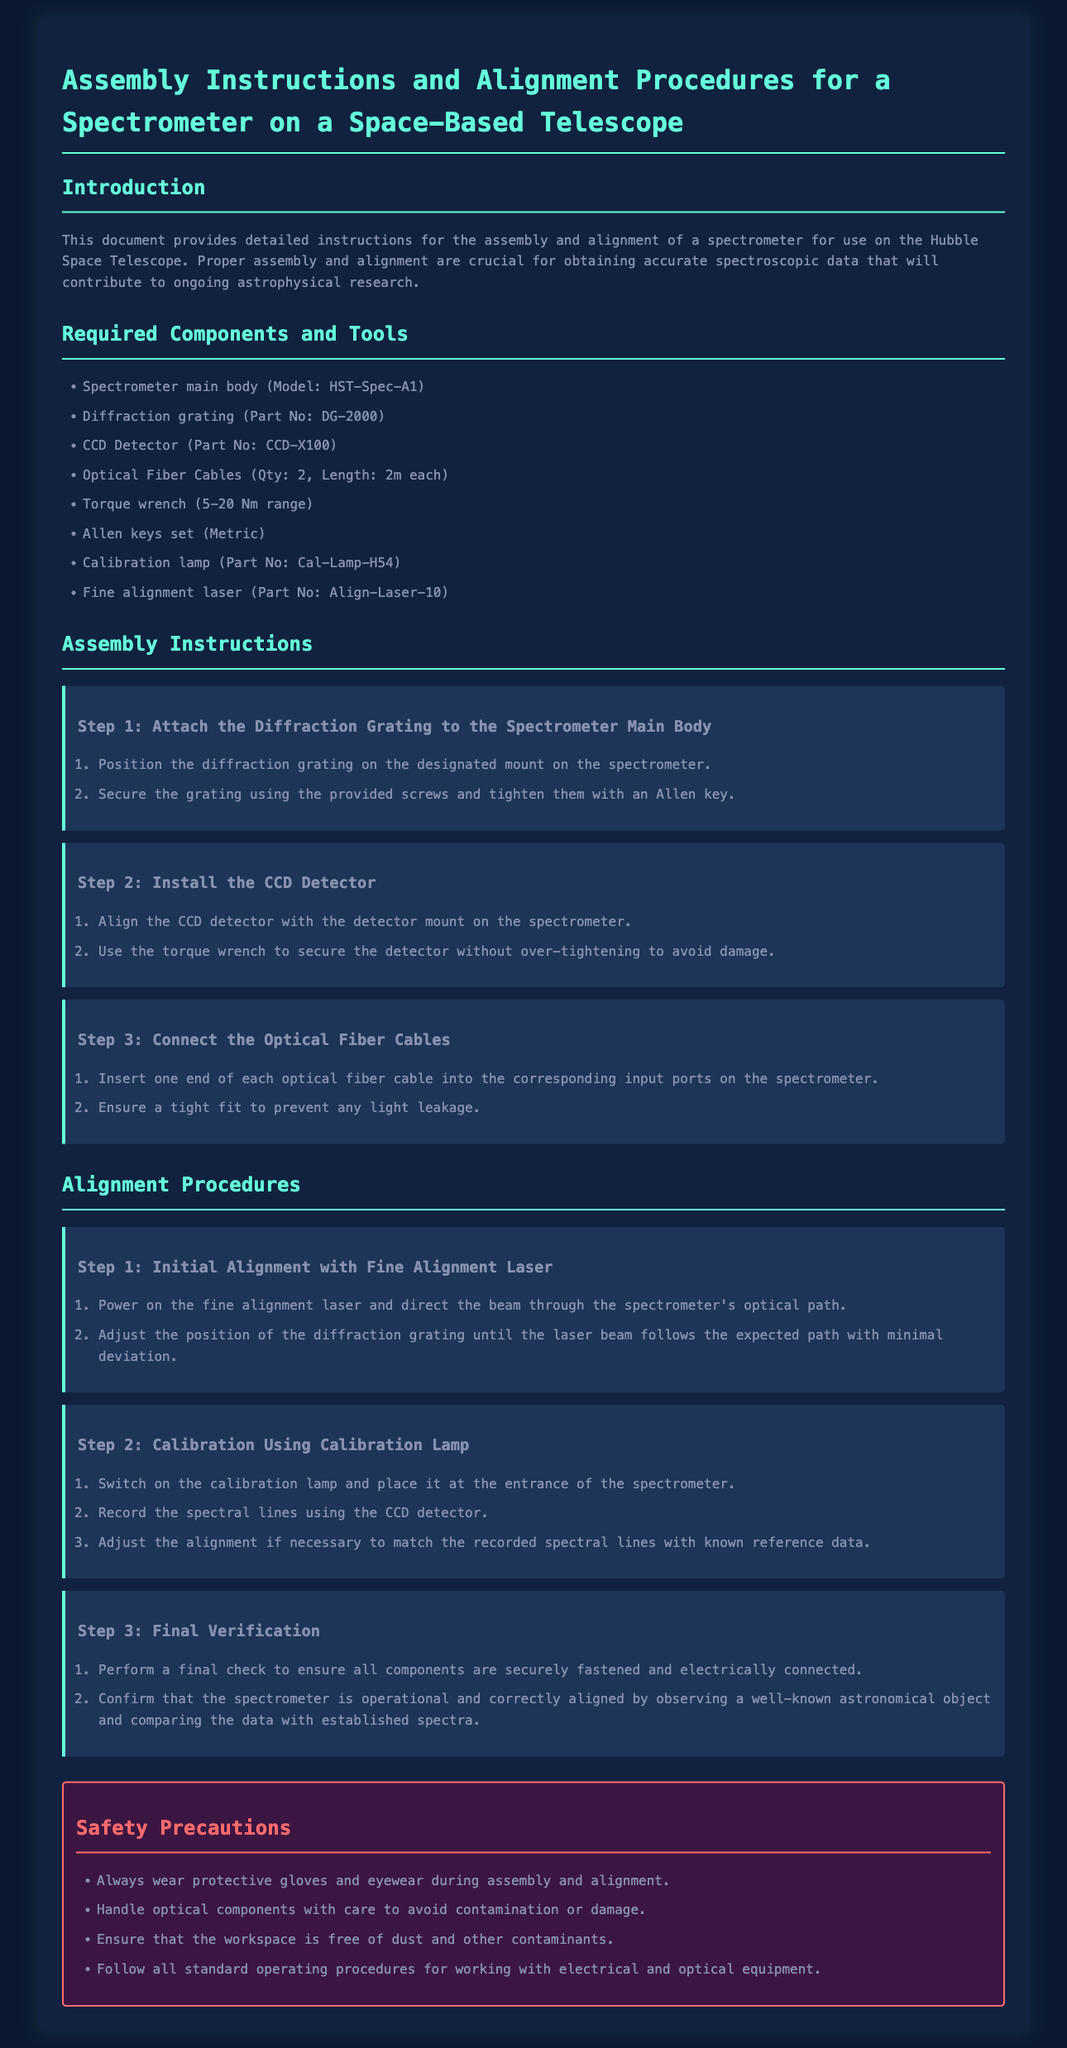What is the model of the spectrometer? The model of the spectrometer mentioned in the document is HST-Spec-A1.
Answer: HST-Spec-A1 How many optical fiber cables are required? The document specifies that two optical fiber cables are required for assembly.
Answer: 2 What is the part number for the diffraction grating? The part number for the diffraction grating is DG-2000.
Answer: DG-2000 What safety precaution is mentioned regarding optical components? The document advises to handle optical components with care to avoid contamination or damage.
Answer: Handle with care What must be used to secure the CCD detector? The document states to use a torque wrench to secure the CCD detector.
Answer: Torque wrench What is the purpose of the calibration lamp? The calibration lamp is used for recording spectral lines during the calibration process.
Answer: Recording spectral lines What is the first step in the assembly instructions? The first step in the assembly instructions is to attach the diffraction grating to the spectrometer main body.
Answer: Attach the diffraction grating How is the initial alignment performed? The initial alignment is performed using a fine alignment laser directed through the spectrometer's optical path.
Answer: Fine alignment laser What should be confirmed in the final verification step? The final verification step requires confirming that the spectrometer is operational and correctly aligned.
Answer: Operational and correctly aligned 